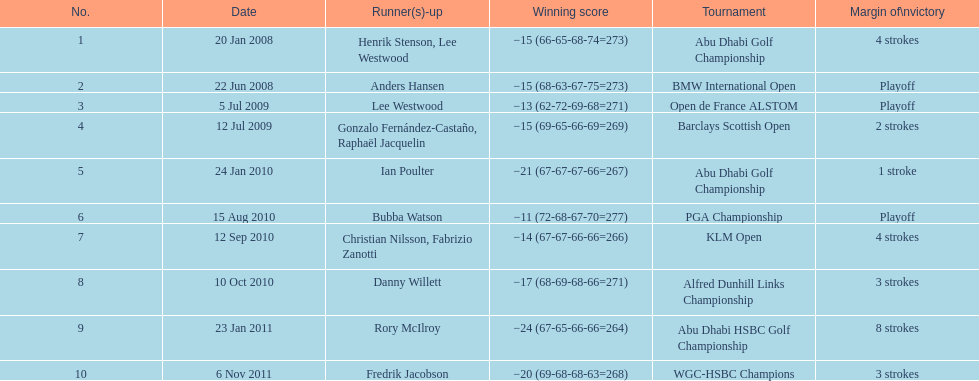Would you be able to parse every entry in this table? {'header': ['No.', 'Date', 'Runner(s)-up', 'Winning score', 'Tournament', 'Margin of\\nvictory'], 'rows': [['1', '20 Jan 2008', 'Henrik Stenson, Lee Westwood', '−15 (66-65-68-74=273)', 'Abu Dhabi Golf Championship', '4 strokes'], ['2', '22 Jun 2008', 'Anders Hansen', '−15 (68-63-67-75=273)', 'BMW International Open', 'Playoff'], ['3', '5 Jul 2009', 'Lee Westwood', '−13 (62-72-69-68=271)', 'Open de France ALSTOM', 'Playoff'], ['4', '12 Jul 2009', 'Gonzalo Fernández-Castaño, Raphaël Jacquelin', '−15 (69-65-66-69=269)', 'Barclays Scottish Open', '2 strokes'], ['5', '24 Jan 2010', 'Ian Poulter', '−21 (67-67-67-66=267)', 'Abu Dhabi Golf Championship', '1 stroke'], ['6', '15 Aug 2010', 'Bubba Watson', '−11 (72-68-67-70=277)', 'PGA Championship', 'Playoff'], ['7', '12 Sep 2010', 'Christian Nilsson, Fabrizio Zanotti', '−14 (67-67-66-66=266)', 'KLM Open', '4 strokes'], ['8', '10 Oct 2010', 'Danny Willett', '−17 (68-69-68-66=271)', 'Alfred Dunhill Links Championship', '3 strokes'], ['9', '23 Jan 2011', 'Rory McIlroy', '−24 (67-65-66-66=264)', 'Abu Dhabi HSBC Golf Championship', '8 strokes'], ['10', '6 Nov 2011', 'Fredrik Jacobson', '−20 (69-68-68-63=268)', 'WGC-HSBC Champions', '3 strokes']]} How many tournaments has he won by 3 or more strokes? 5. 